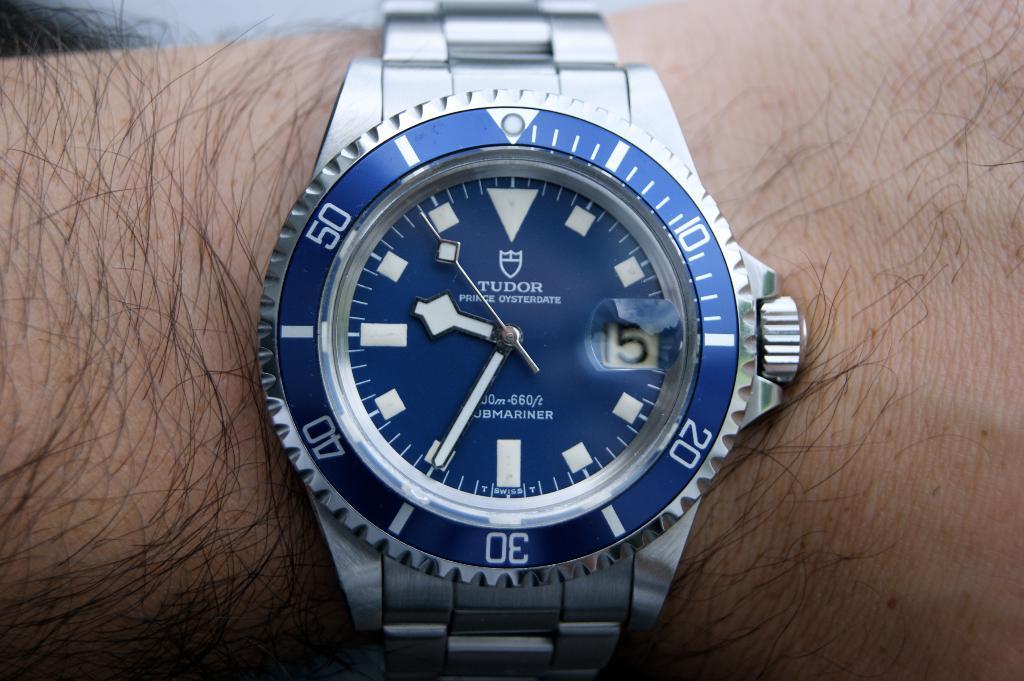What brand is the watch?
Offer a terse response. Tudor. What time does the watch say?
Your answer should be compact. 9:35. 